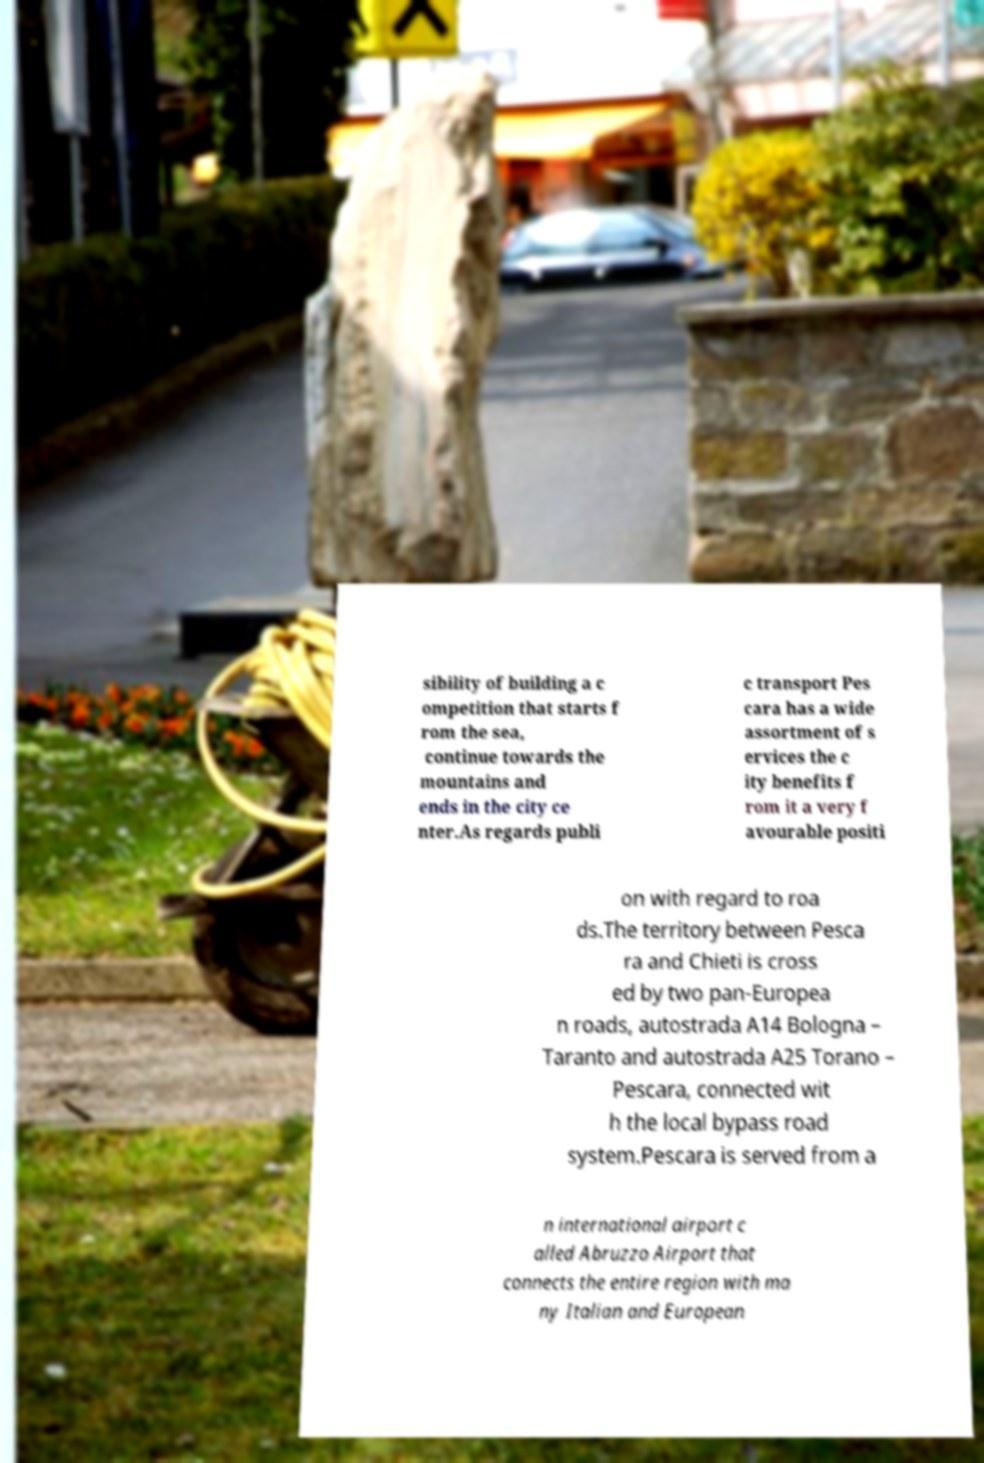There's text embedded in this image that I need extracted. Can you transcribe it verbatim? sibility of building a c ompetition that starts f rom the sea, continue towards the mountains and ends in the city ce nter.As regards publi c transport Pes cara has a wide assortment of s ervices the c ity benefits f rom it a very f avourable positi on with regard to roa ds.The territory between Pesca ra and Chieti is cross ed by two pan-Europea n roads, autostrada A14 Bologna – Taranto and autostrada A25 Torano – Pescara, connected wit h the local bypass road system.Pescara is served from a n international airport c alled Abruzzo Airport that connects the entire region with ma ny Italian and European 